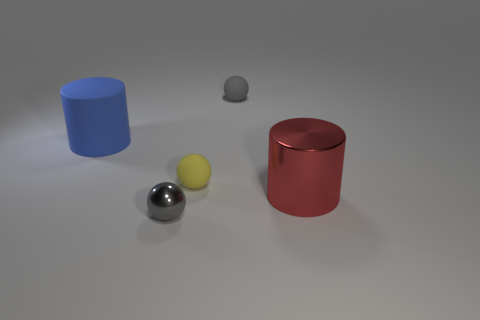Add 3 small metal balls. How many objects exist? 8 Subtract all balls. How many objects are left? 2 Subtract 0 yellow cylinders. How many objects are left? 5 Subtract all big blue rubber cylinders. Subtract all large red cylinders. How many objects are left? 3 Add 2 tiny gray shiny spheres. How many tiny gray shiny spheres are left? 3 Add 1 gray matte spheres. How many gray matte spheres exist? 2 